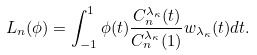Convert formula to latex. <formula><loc_0><loc_0><loc_500><loc_500>L _ { n } ( \phi ) = \int _ { - 1 } ^ { 1 } \phi ( t ) \frac { C _ { n } ^ { \lambda _ { \kappa } } ( t ) } { C _ { n } ^ { \lambda _ { \kappa } } ( 1 ) } w _ { \lambda _ { \kappa } } ( t ) d t .</formula> 